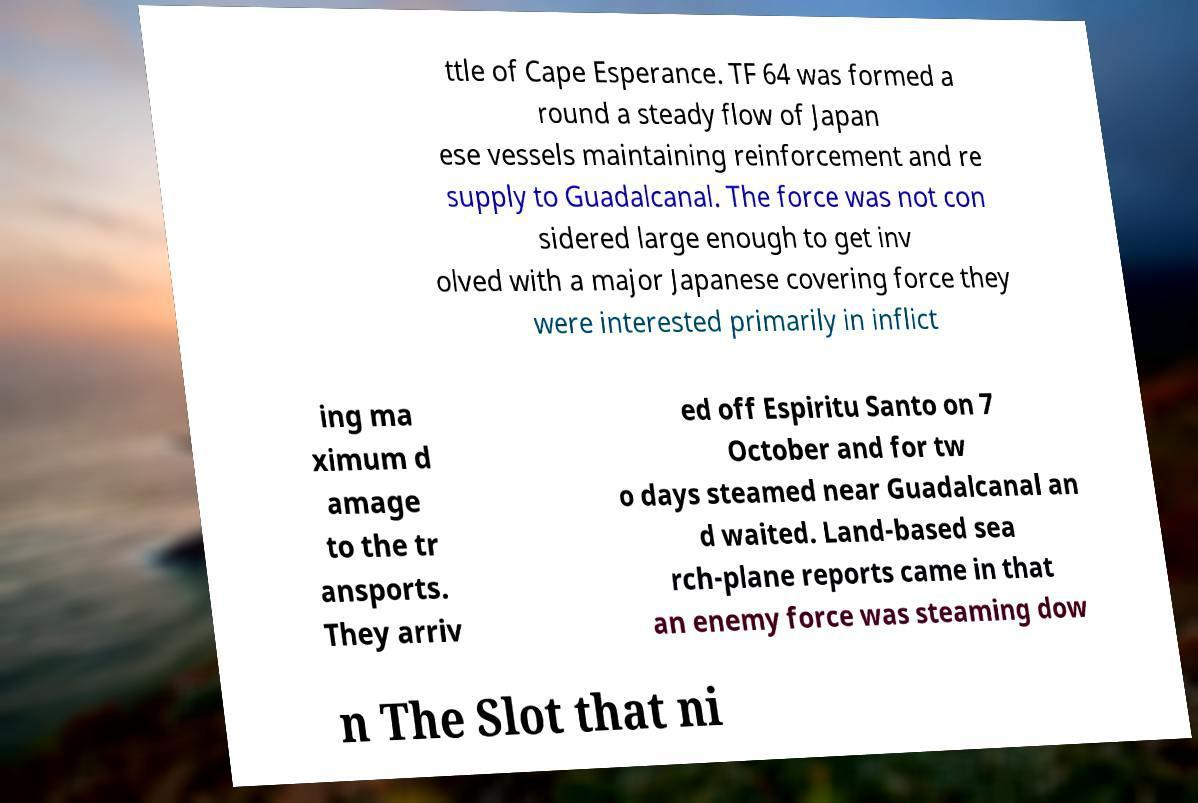Can you read and provide the text displayed in the image?This photo seems to have some interesting text. Can you extract and type it out for me? ttle of Cape Esperance. TF 64 was formed a round a steady flow of Japan ese vessels maintaining reinforcement and re supply to Guadalcanal. The force was not con sidered large enough to get inv olved with a major Japanese covering force they were interested primarily in inflict ing ma ximum d amage to the tr ansports. They arriv ed off Espiritu Santo on 7 October and for tw o days steamed near Guadalcanal an d waited. Land-based sea rch-plane reports came in that an enemy force was steaming dow n The Slot that ni 